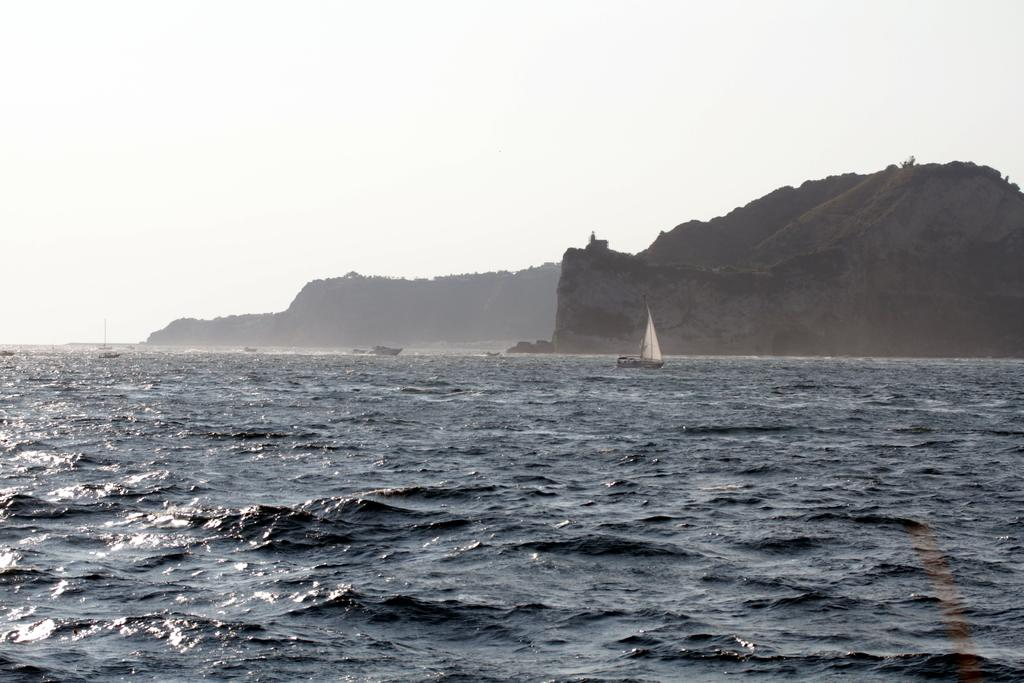What is the main subject of the image? The main subject of the image is an ocean. Are there any objects or structures in the ocean? Yes, there are boats in the ocean. What can be seen on the right side of the image? There appears to be a mountain on the right side of the image. What is visible at the top of the image? The sky is visible at the top of the image. Where is the glue being used in the image? There is no glue present in the image. Can you see a fireman in the image? No, there is no fireman in the image. Are there any cows visible in the image? No, there are no cows in the image. 